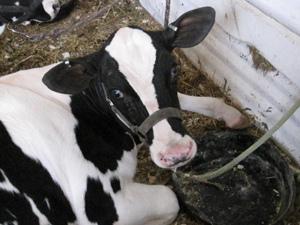What color is the cow's tag?
Quick response, please. White. What is the cow eating?
Give a very brief answer. Grass. How many cow's eyes do you see?
Write a very short answer. 2. What type of animal is pictured?
Answer briefly. Cow. Why is the animal tied?
Quick response, please. To keep in stall. Where is the water?
Write a very short answer. In bowl. Is the animal standing?
Keep it brief. No. 